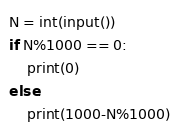Convert code to text. <code><loc_0><loc_0><loc_500><loc_500><_Python_>N = int(input())
if N%1000 == 0:
    print(0)
else:
    print(1000-N%1000)</code> 